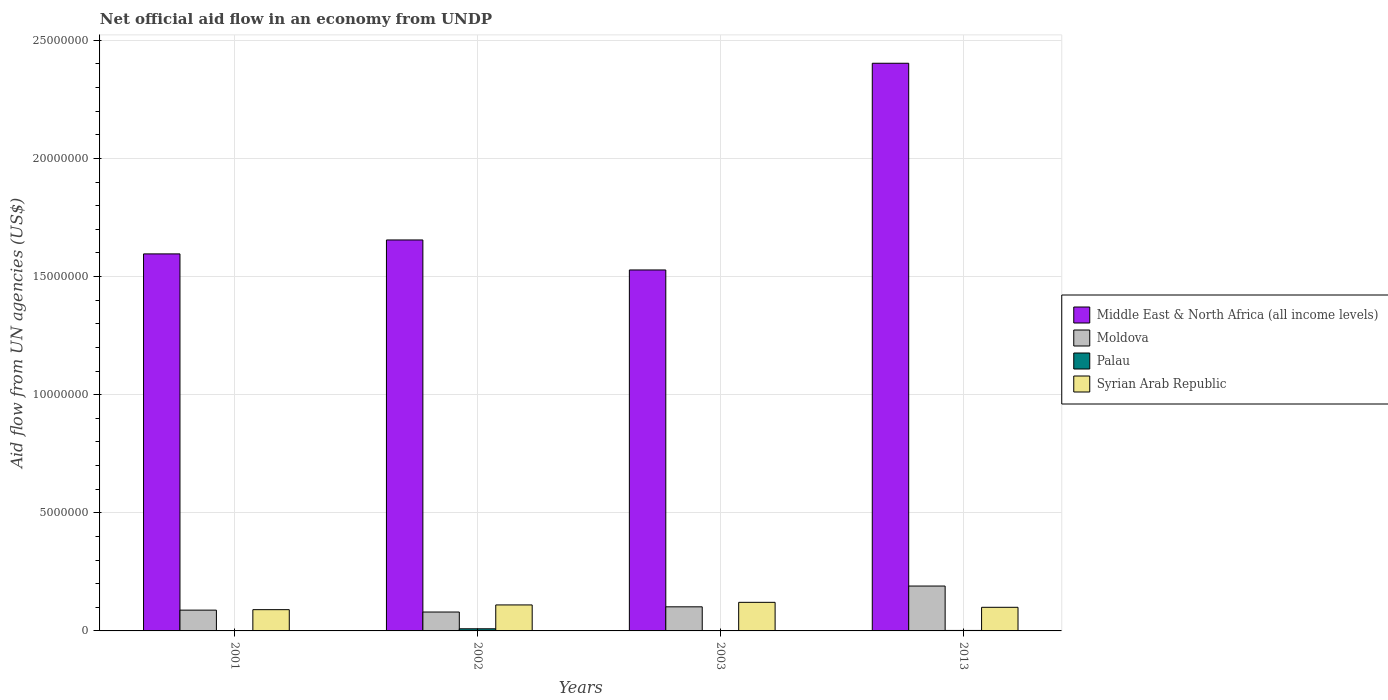How many different coloured bars are there?
Offer a terse response. 4. How many bars are there on the 3rd tick from the right?
Offer a terse response. 4. What is the label of the 4th group of bars from the left?
Provide a short and direct response. 2013. What is the net official aid flow in Syrian Arab Republic in 2013?
Provide a short and direct response. 1.00e+06. Across all years, what is the maximum net official aid flow in Moldova?
Your answer should be compact. 1.90e+06. Across all years, what is the minimum net official aid flow in Syrian Arab Republic?
Provide a short and direct response. 9.00e+05. In which year was the net official aid flow in Syrian Arab Republic maximum?
Offer a terse response. 2003. In which year was the net official aid flow in Syrian Arab Republic minimum?
Your answer should be very brief. 2001. What is the total net official aid flow in Middle East & North Africa (all income levels) in the graph?
Provide a succinct answer. 7.18e+07. What is the difference between the net official aid flow in Middle East & North Africa (all income levels) in 2002 and that in 2013?
Make the answer very short. -7.48e+06. What is the difference between the net official aid flow in Middle East & North Africa (all income levels) in 2002 and the net official aid flow in Palau in 2013?
Give a very brief answer. 1.65e+07. What is the average net official aid flow in Palau per year?
Your response must be concise. 3.25e+04. In the year 2001, what is the difference between the net official aid flow in Moldova and net official aid flow in Palau?
Your answer should be very brief. 8.70e+05. What is the ratio of the net official aid flow in Syrian Arab Republic in 2001 to that in 2002?
Your answer should be compact. 0.82. What is the difference between the highest and the second highest net official aid flow in Middle East & North Africa (all income levels)?
Ensure brevity in your answer.  7.48e+06. What is the difference between the highest and the lowest net official aid flow in Middle East & North Africa (all income levels)?
Keep it short and to the point. 8.75e+06. Is the sum of the net official aid flow in Moldova in 2002 and 2003 greater than the maximum net official aid flow in Middle East & North Africa (all income levels) across all years?
Offer a very short reply. No. Is it the case that in every year, the sum of the net official aid flow in Moldova and net official aid flow in Palau is greater than the sum of net official aid flow in Middle East & North Africa (all income levels) and net official aid flow in Syrian Arab Republic?
Provide a succinct answer. Yes. What does the 3rd bar from the left in 2013 represents?
Your answer should be very brief. Palau. What does the 2nd bar from the right in 2002 represents?
Offer a terse response. Palau. Is it the case that in every year, the sum of the net official aid flow in Syrian Arab Republic and net official aid flow in Moldova is greater than the net official aid flow in Middle East & North Africa (all income levels)?
Offer a terse response. No. How many bars are there?
Give a very brief answer. 16. Does the graph contain any zero values?
Provide a succinct answer. No. Where does the legend appear in the graph?
Provide a short and direct response. Center right. How are the legend labels stacked?
Provide a short and direct response. Vertical. What is the title of the graph?
Your answer should be very brief. Net official aid flow in an economy from UNDP. Does "Grenada" appear as one of the legend labels in the graph?
Make the answer very short. No. What is the label or title of the Y-axis?
Give a very brief answer. Aid flow from UN agencies (US$). What is the Aid flow from UN agencies (US$) in Middle East & North Africa (all income levels) in 2001?
Give a very brief answer. 1.60e+07. What is the Aid flow from UN agencies (US$) in Moldova in 2001?
Offer a very short reply. 8.80e+05. What is the Aid flow from UN agencies (US$) in Syrian Arab Republic in 2001?
Your answer should be compact. 9.00e+05. What is the Aid flow from UN agencies (US$) of Middle East & North Africa (all income levels) in 2002?
Offer a terse response. 1.66e+07. What is the Aid flow from UN agencies (US$) of Moldova in 2002?
Your answer should be very brief. 8.00e+05. What is the Aid flow from UN agencies (US$) of Syrian Arab Republic in 2002?
Offer a terse response. 1.10e+06. What is the Aid flow from UN agencies (US$) in Middle East & North Africa (all income levels) in 2003?
Your answer should be compact. 1.53e+07. What is the Aid flow from UN agencies (US$) in Moldova in 2003?
Offer a very short reply. 1.02e+06. What is the Aid flow from UN agencies (US$) of Syrian Arab Republic in 2003?
Offer a very short reply. 1.21e+06. What is the Aid flow from UN agencies (US$) of Middle East & North Africa (all income levels) in 2013?
Give a very brief answer. 2.40e+07. What is the Aid flow from UN agencies (US$) in Moldova in 2013?
Your answer should be very brief. 1.90e+06. What is the Aid flow from UN agencies (US$) in Syrian Arab Republic in 2013?
Give a very brief answer. 1.00e+06. Across all years, what is the maximum Aid flow from UN agencies (US$) in Middle East & North Africa (all income levels)?
Offer a very short reply. 2.40e+07. Across all years, what is the maximum Aid flow from UN agencies (US$) of Moldova?
Offer a very short reply. 1.90e+06. Across all years, what is the maximum Aid flow from UN agencies (US$) in Syrian Arab Republic?
Your answer should be very brief. 1.21e+06. Across all years, what is the minimum Aid flow from UN agencies (US$) in Middle East & North Africa (all income levels)?
Keep it short and to the point. 1.53e+07. Across all years, what is the minimum Aid flow from UN agencies (US$) in Moldova?
Your response must be concise. 8.00e+05. What is the total Aid flow from UN agencies (US$) of Middle East & North Africa (all income levels) in the graph?
Your answer should be very brief. 7.18e+07. What is the total Aid flow from UN agencies (US$) in Moldova in the graph?
Your response must be concise. 4.60e+06. What is the total Aid flow from UN agencies (US$) in Palau in the graph?
Provide a short and direct response. 1.30e+05. What is the total Aid flow from UN agencies (US$) of Syrian Arab Republic in the graph?
Your response must be concise. 4.21e+06. What is the difference between the Aid flow from UN agencies (US$) in Middle East & North Africa (all income levels) in 2001 and that in 2002?
Your answer should be compact. -5.90e+05. What is the difference between the Aid flow from UN agencies (US$) in Moldova in 2001 and that in 2002?
Keep it short and to the point. 8.00e+04. What is the difference between the Aid flow from UN agencies (US$) in Middle East & North Africa (all income levels) in 2001 and that in 2003?
Your response must be concise. 6.80e+05. What is the difference between the Aid flow from UN agencies (US$) of Syrian Arab Republic in 2001 and that in 2003?
Keep it short and to the point. -3.10e+05. What is the difference between the Aid flow from UN agencies (US$) of Middle East & North Africa (all income levels) in 2001 and that in 2013?
Make the answer very short. -8.07e+06. What is the difference between the Aid flow from UN agencies (US$) in Moldova in 2001 and that in 2013?
Your response must be concise. -1.02e+06. What is the difference between the Aid flow from UN agencies (US$) in Syrian Arab Republic in 2001 and that in 2013?
Give a very brief answer. -1.00e+05. What is the difference between the Aid flow from UN agencies (US$) of Middle East & North Africa (all income levels) in 2002 and that in 2003?
Give a very brief answer. 1.27e+06. What is the difference between the Aid flow from UN agencies (US$) of Moldova in 2002 and that in 2003?
Your answer should be very brief. -2.20e+05. What is the difference between the Aid flow from UN agencies (US$) of Middle East & North Africa (all income levels) in 2002 and that in 2013?
Provide a succinct answer. -7.48e+06. What is the difference between the Aid flow from UN agencies (US$) of Moldova in 2002 and that in 2013?
Offer a terse response. -1.10e+06. What is the difference between the Aid flow from UN agencies (US$) of Middle East & North Africa (all income levels) in 2003 and that in 2013?
Ensure brevity in your answer.  -8.75e+06. What is the difference between the Aid flow from UN agencies (US$) of Moldova in 2003 and that in 2013?
Provide a succinct answer. -8.80e+05. What is the difference between the Aid flow from UN agencies (US$) of Syrian Arab Republic in 2003 and that in 2013?
Your answer should be very brief. 2.10e+05. What is the difference between the Aid flow from UN agencies (US$) of Middle East & North Africa (all income levels) in 2001 and the Aid flow from UN agencies (US$) of Moldova in 2002?
Give a very brief answer. 1.52e+07. What is the difference between the Aid flow from UN agencies (US$) of Middle East & North Africa (all income levels) in 2001 and the Aid flow from UN agencies (US$) of Palau in 2002?
Offer a terse response. 1.59e+07. What is the difference between the Aid flow from UN agencies (US$) in Middle East & North Africa (all income levels) in 2001 and the Aid flow from UN agencies (US$) in Syrian Arab Republic in 2002?
Your response must be concise. 1.49e+07. What is the difference between the Aid flow from UN agencies (US$) of Moldova in 2001 and the Aid flow from UN agencies (US$) of Palau in 2002?
Offer a terse response. 7.90e+05. What is the difference between the Aid flow from UN agencies (US$) in Moldova in 2001 and the Aid flow from UN agencies (US$) in Syrian Arab Republic in 2002?
Provide a succinct answer. -2.20e+05. What is the difference between the Aid flow from UN agencies (US$) of Palau in 2001 and the Aid flow from UN agencies (US$) of Syrian Arab Republic in 2002?
Provide a succinct answer. -1.09e+06. What is the difference between the Aid flow from UN agencies (US$) of Middle East & North Africa (all income levels) in 2001 and the Aid flow from UN agencies (US$) of Moldova in 2003?
Keep it short and to the point. 1.49e+07. What is the difference between the Aid flow from UN agencies (US$) in Middle East & North Africa (all income levels) in 2001 and the Aid flow from UN agencies (US$) in Palau in 2003?
Offer a very short reply. 1.60e+07. What is the difference between the Aid flow from UN agencies (US$) of Middle East & North Africa (all income levels) in 2001 and the Aid flow from UN agencies (US$) of Syrian Arab Republic in 2003?
Your answer should be very brief. 1.48e+07. What is the difference between the Aid flow from UN agencies (US$) in Moldova in 2001 and the Aid flow from UN agencies (US$) in Palau in 2003?
Give a very brief answer. 8.70e+05. What is the difference between the Aid flow from UN agencies (US$) in Moldova in 2001 and the Aid flow from UN agencies (US$) in Syrian Arab Republic in 2003?
Make the answer very short. -3.30e+05. What is the difference between the Aid flow from UN agencies (US$) of Palau in 2001 and the Aid flow from UN agencies (US$) of Syrian Arab Republic in 2003?
Offer a terse response. -1.20e+06. What is the difference between the Aid flow from UN agencies (US$) in Middle East & North Africa (all income levels) in 2001 and the Aid flow from UN agencies (US$) in Moldova in 2013?
Ensure brevity in your answer.  1.41e+07. What is the difference between the Aid flow from UN agencies (US$) in Middle East & North Africa (all income levels) in 2001 and the Aid flow from UN agencies (US$) in Palau in 2013?
Your answer should be very brief. 1.59e+07. What is the difference between the Aid flow from UN agencies (US$) of Middle East & North Africa (all income levels) in 2001 and the Aid flow from UN agencies (US$) of Syrian Arab Republic in 2013?
Your answer should be very brief. 1.50e+07. What is the difference between the Aid flow from UN agencies (US$) of Moldova in 2001 and the Aid flow from UN agencies (US$) of Palau in 2013?
Ensure brevity in your answer.  8.60e+05. What is the difference between the Aid flow from UN agencies (US$) of Palau in 2001 and the Aid flow from UN agencies (US$) of Syrian Arab Republic in 2013?
Your response must be concise. -9.90e+05. What is the difference between the Aid flow from UN agencies (US$) of Middle East & North Africa (all income levels) in 2002 and the Aid flow from UN agencies (US$) of Moldova in 2003?
Ensure brevity in your answer.  1.55e+07. What is the difference between the Aid flow from UN agencies (US$) in Middle East & North Africa (all income levels) in 2002 and the Aid flow from UN agencies (US$) in Palau in 2003?
Make the answer very short. 1.65e+07. What is the difference between the Aid flow from UN agencies (US$) in Middle East & North Africa (all income levels) in 2002 and the Aid flow from UN agencies (US$) in Syrian Arab Republic in 2003?
Your answer should be very brief. 1.53e+07. What is the difference between the Aid flow from UN agencies (US$) in Moldova in 2002 and the Aid flow from UN agencies (US$) in Palau in 2003?
Provide a short and direct response. 7.90e+05. What is the difference between the Aid flow from UN agencies (US$) in Moldova in 2002 and the Aid flow from UN agencies (US$) in Syrian Arab Republic in 2003?
Your response must be concise. -4.10e+05. What is the difference between the Aid flow from UN agencies (US$) of Palau in 2002 and the Aid flow from UN agencies (US$) of Syrian Arab Republic in 2003?
Your answer should be very brief. -1.12e+06. What is the difference between the Aid flow from UN agencies (US$) of Middle East & North Africa (all income levels) in 2002 and the Aid flow from UN agencies (US$) of Moldova in 2013?
Your answer should be compact. 1.46e+07. What is the difference between the Aid flow from UN agencies (US$) in Middle East & North Africa (all income levels) in 2002 and the Aid flow from UN agencies (US$) in Palau in 2013?
Your answer should be compact. 1.65e+07. What is the difference between the Aid flow from UN agencies (US$) of Middle East & North Africa (all income levels) in 2002 and the Aid flow from UN agencies (US$) of Syrian Arab Republic in 2013?
Your answer should be very brief. 1.56e+07. What is the difference between the Aid flow from UN agencies (US$) in Moldova in 2002 and the Aid flow from UN agencies (US$) in Palau in 2013?
Your answer should be compact. 7.80e+05. What is the difference between the Aid flow from UN agencies (US$) of Moldova in 2002 and the Aid flow from UN agencies (US$) of Syrian Arab Republic in 2013?
Keep it short and to the point. -2.00e+05. What is the difference between the Aid flow from UN agencies (US$) in Palau in 2002 and the Aid flow from UN agencies (US$) in Syrian Arab Republic in 2013?
Your response must be concise. -9.10e+05. What is the difference between the Aid flow from UN agencies (US$) in Middle East & North Africa (all income levels) in 2003 and the Aid flow from UN agencies (US$) in Moldova in 2013?
Provide a succinct answer. 1.34e+07. What is the difference between the Aid flow from UN agencies (US$) in Middle East & North Africa (all income levels) in 2003 and the Aid flow from UN agencies (US$) in Palau in 2013?
Ensure brevity in your answer.  1.53e+07. What is the difference between the Aid flow from UN agencies (US$) in Middle East & North Africa (all income levels) in 2003 and the Aid flow from UN agencies (US$) in Syrian Arab Republic in 2013?
Offer a terse response. 1.43e+07. What is the difference between the Aid flow from UN agencies (US$) in Moldova in 2003 and the Aid flow from UN agencies (US$) in Syrian Arab Republic in 2013?
Offer a terse response. 2.00e+04. What is the difference between the Aid flow from UN agencies (US$) in Palau in 2003 and the Aid flow from UN agencies (US$) in Syrian Arab Republic in 2013?
Provide a short and direct response. -9.90e+05. What is the average Aid flow from UN agencies (US$) in Middle East & North Africa (all income levels) per year?
Your answer should be very brief. 1.80e+07. What is the average Aid flow from UN agencies (US$) in Moldova per year?
Provide a succinct answer. 1.15e+06. What is the average Aid flow from UN agencies (US$) in Palau per year?
Offer a terse response. 3.25e+04. What is the average Aid flow from UN agencies (US$) of Syrian Arab Republic per year?
Your answer should be very brief. 1.05e+06. In the year 2001, what is the difference between the Aid flow from UN agencies (US$) of Middle East & North Africa (all income levels) and Aid flow from UN agencies (US$) of Moldova?
Provide a succinct answer. 1.51e+07. In the year 2001, what is the difference between the Aid flow from UN agencies (US$) in Middle East & North Africa (all income levels) and Aid flow from UN agencies (US$) in Palau?
Provide a succinct answer. 1.60e+07. In the year 2001, what is the difference between the Aid flow from UN agencies (US$) of Middle East & North Africa (all income levels) and Aid flow from UN agencies (US$) of Syrian Arab Republic?
Your answer should be compact. 1.51e+07. In the year 2001, what is the difference between the Aid flow from UN agencies (US$) in Moldova and Aid flow from UN agencies (US$) in Palau?
Provide a succinct answer. 8.70e+05. In the year 2001, what is the difference between the Aid flow from UN agencies (US$) of Moldova and Aid flow from UN agencies (US$) of Syrian Arab Republic?
Your response must be concise. -2.00e+04. In the year 2001, what is the difference between the Aid flow from UN agencies (US$) in Palau and Aid flow from UN agencies (US$) in Syrian Arab Republic?
Offer a very short reply. -8.90e+05. In the year 2002, what is the difference between the Aid flow from UN agencies (US$) in Middle East & North Africa (all income levels) and Aid flow from UN agencies (US$) in Moldova?
Your response must be concise. 1.58e+07. In the year 2002, what is the difference between the Aid flow from UN agencies (US$) of Middle East & North Africa (all income levels) and Aid flow from UN agencies (US$) of Palau?
Your response must be concise. 1.65e+07. In the year 2002, what is the difference between the Aid flow from UN agencies (US$) in Middle East & North Africa (all income levels) and Aid flow from UN agencies (US$) in Syrian Arab Republic?
Make the answer very short. 1.54e+07. In the year 2002, what is the difference between the Aid flow from UN agencies (US$) of Moldova and Aid flow from UN agencies (US$) of Palau?
Keep it short and to the point. 7.10e+05. In the year 2002, what is the difference between the Aid flow from UN agencies (US$) of Moldova and Aid flow from UN agencies (US$) of Syrian Arab Republic?
Provide a short and direct response. -3.00e+05. In the year 2002, what is the difference between the Aid flow from UN agencies (US$) in Palau and Aid flow from UN agencies (US$) in Syrian Arab Republic?
Your answer should be very brief. -1.01e+06. In the year 2003, what is the difference between the Aid flow from UN agencies (US$) of Middle East & North Africa (all income levels) and Aid flow from UN agencies (US$) of Moldova?
Your response must be concise. 1.43e+07. In the year 2003, what is the difference between the Aid flow from UN agencies (US$) of Middle East & North Africa (all income levels) and Aid flow from UN agencies (US$) of Palau?
Provide a short and direct response. 1.53e+07. In the year 2003, what is the difference between the Aid flow from UN agencies (US$) of Middle East & North Africa (all income levels) and Aid flow from UN agencies (US$) of Syrian Arab Republic?
Ensure brevity in your answer.  1.41e+07. In the year 2003, what is the difference between the Aid flow from UN agencies (US$) of Moldova and Aid flow from UN agencies (US$) of Palau?
Keep it short and to the point. 1.01e+06. In the year 2003, what is the difference between the Aid flow from UN agencies (US$) of Palau and Aid flow from UN agencies (US$) of Syrian Arab Republic?
Provide a short and direct response. -1.20e+06. In the year 2013, what is the difference between the Aid flow from UN agencies (US$) of Middle East & North Africa (all income levels) and Aid flow from UN agencies (US$) of Moldova?
Provide a short and direct response. 2.21e+07. In the year 2013, what is the difference between the Aid flow from UN agencies (US$) of Middle East & North Africa (all income levels) and Aid flow from UN agencies (US$) of Palau?
Ensure brevity in your answer.  2.40e+07. In the year 2013, what is the difference between the Aid flow from UN agencies (US$) in Middle East & North Africa (all income levels) and Aid flow from UN agencies (US$) in Syrian Arab Republic?
Provide a succinct answer. 2.30e+07. In the year 2013, what is the difference between the Aid flow from UN agencies (US$) of Moldova and Aid flow from UN agencies (US$) of Palau?
Your answer should be compact. 1.88e+06. In the year 2013, what is the difference between the Aid flow from UN agencies (US$) in Palau and Aid flow from UN agencies (US$) in Syrian Arab Republic?
Keep it short and to the point. -9.80e+05. What is the ratio of the Aid flow from UN agencies (US$) of Middle East & North Africa (all income levels) in 2001 to that in 2002?
Offer a very short reply. 0.96. What is the ratio of the Aid flow from UN agencies (US$) in Moldova in 2001 to that in 2002?
Offer a very short reply. 1.1. What is the ratio of the Aid flow from UN agencies (US$) in Palau in 2001 to that in 2002?
Ensure brevity in your answer.  0.11. What is the ratio of the Aid flow from UN agencies (US$) in Syrian Arab Republic in 2001 to that in 2002?
Keep it short and to the point. 0.82. What is the ratio of the Aid flow from UN agencies (US$) in Middle East & North Africa (all income levels) in 2001 to that in 2003?
Ensure brevity in your answer.  1.04. What is the ratio of the Aid flow from UN agencies (US$) of Moldova in 2001 to that in 2003?
Provide a succinct answer. 0.86. What is the ratio of the Aid flow from UN agencies (US$) of Palau in 2001 to that in 2003?
Your answer should be compact. 1. What is the ratio of the Aid flow from UN agencies (US$) of Syrian Arab Republic in 2001 to that in 2003?
Your answer should be very brief. 0.74. What is the ratio of the Aid flow from UN agencies (US$) of Middle East & North Africa (all income levels) in 2001 to that in 2013?
Keep it short and to the point. 0.66. What is the ratio of the Aid flow from UN agencies (US$) in Moldova in 2001 to that in 2013?
Give a very brief answer. 0.46. What is the ratio of the Aid flow from UN agencies (US$) in Palau in 2001 to that in 2013?
Provide a short and direct response. 0.5. What is the ratio of the Aid flow from UN agencies (US$) of Middle East & North Africa (all income levels) in 2002 to that in 2003?
Offer a very short reply. 1.08. What is the ratio of the Aid flow from UN agencies (US$) in Moldova in 2002 to that in 2003?
Your response must be concise. 0.78. What is the ratio of the Aid flow from UN agencies (US$) of Syrian Arab Republic in 2002 to that in 2003?
Provide a succinct answer. 0.91. What is the ratio of the Aid flow from UN agencies (US$) in Middle East & North Africa (all income levels) in 2002 to that in 2013?
Offer a terse response. 0.69. What is the ratio of the Aid flow from UN agencies (US$) of Moldova in 2002 to that in 2013?
Your response must be concise. 0.42. What is the ratio of the Aid flow from UN agencies (US$) in Middle East & North Africa (all income levels) in 2003 to that in 2013?
Your answer should be very brief. 0.64. What is the ratio of the Aid flow from UN agencies (US$) of Moldova in 2003 to that in 2013?
Ensure brevity in your answer.  0.54. What is the ratio of the Aid flow from UN agencies (US$) in Palau in 2003 to that in 2013?
Offer a terse response. 0.5. What is the ratio of the Aid flow from UN agencies (US$) in Syrian Arab Republic in 2003 to that in 2013?
Ensure brevity in your answer.  1.21. What is the difference between the highest and the second highest Aid flow from UN agencies (US$) of Middle East & North Africa (all income levels)?
Keep it short and to the point. 7.48e+06. What is the difference between the highest and the second highest Aid flow from UN agencies (US$) in Moldova?
Your response must be concise. 8.80e+05. What is the difference between the highest and the second highest Aid flow from UN agencies (US$) in Palau?
Ensure brevity in your answer.  7.00e+04. What is the difference between the highest and the second highest Aid flow from UN agencies (US$) of Syrian Arab Republic?
Offer a very short reply. 1.10e+05. What is the difference between the highest and the lowest Aid flow from UN agencies (US$) in Middle East & North Africa (all income levels)?
Offer a very short reply. 8.75e+06. What is the difference between the highest and the lowest Aid flow from UN agencies (US$) in Moldova?
Provide a short and direct response. 1.10e+06. What is the difference between the highest and the lowest Aid flow from UN agencies (US$) in Palau?
Make the answer very short. 8.00e+04. What is the difference between the highest and the lowest Aid flow from UN agencies (US$) of Syrian Arab Republic?
Give a very brief answer. 3.10e+05. 